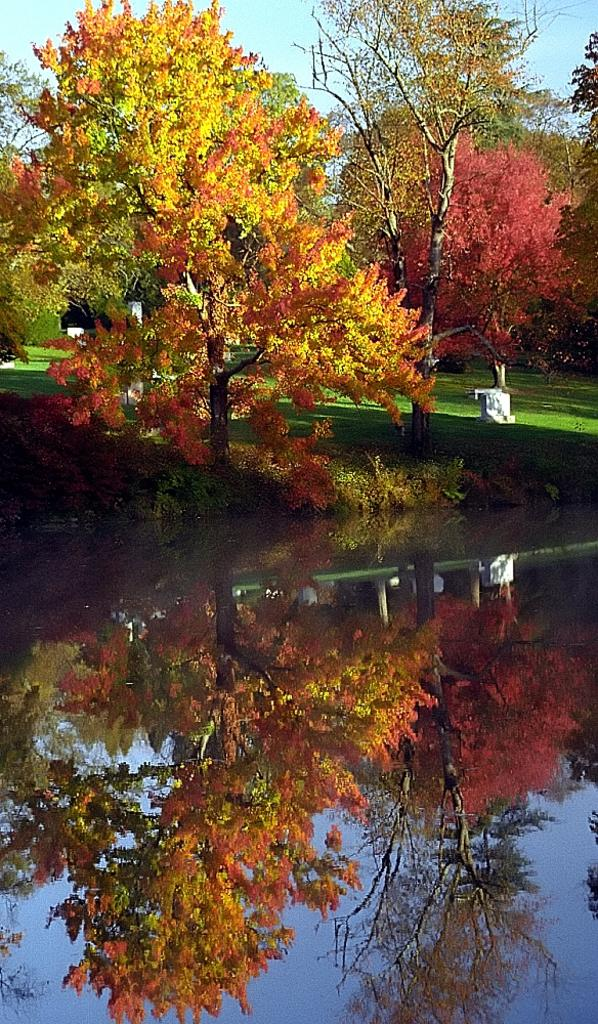What is one of the natural elements present in the image? There is water in the image. What type of vegetation can be seen in the image? There is grass and trees in the image. What is visible at the top of the image? The sky is visible at the top of the image. What type of map is being used by the crook in the image? There is no crook or map present in the image. 